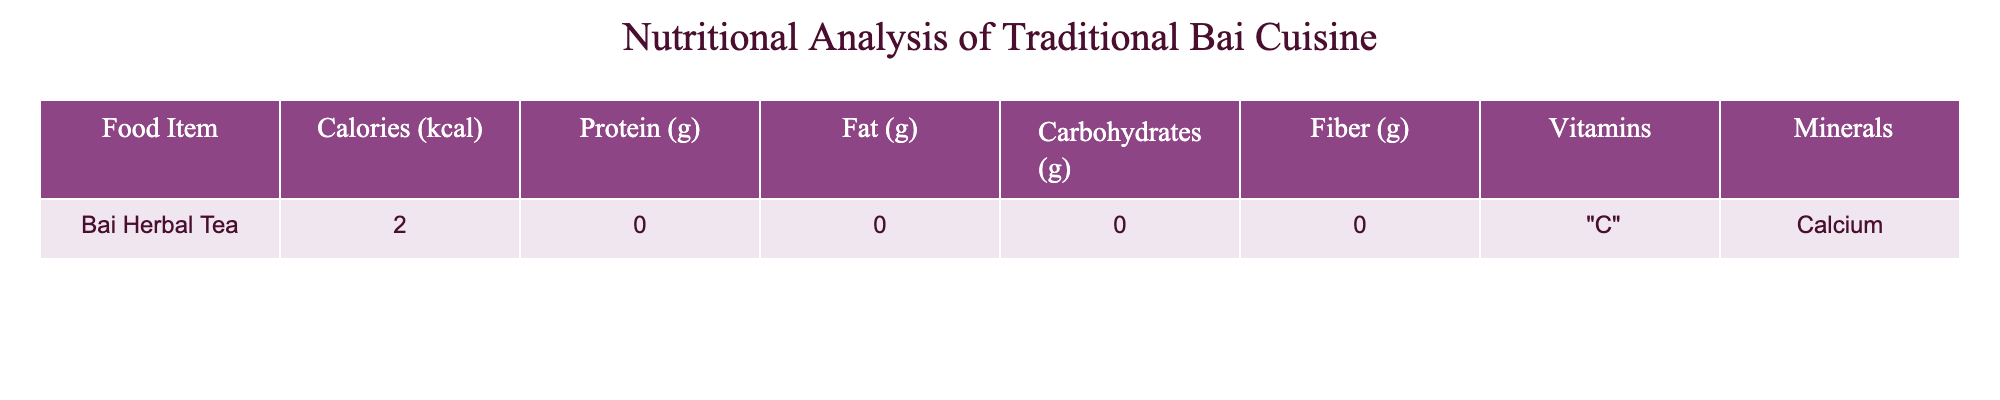What is the calorie content of Bai Herbal Tea? The calorie content of Bai Herbal Tea is listed directly in the table under the "Calories (kcal)" column.
Answer: 2 kcal Does Bai Herbal Tea contain any protein? The "Protein (g)" column indicates that Bai Herbal Tea has 0 grams of protein.
Answer: No What is the total fat content in Bai Herbal Tea? The table shows a total fat content of 0 grams for Bai Herbal Tea in the "Fat (g)" column.
Answer: 0 g Is Bai Herbal Tea a significant source of vitamins? The table indicates that Bai Herbal Tea contains Vitamin C, which is a significant vitamin, thus it qualifies as a source of vitamins.
Answer: Yes If you were to consume 3 servings of Bai Herbal Tea, how many calories would that amount to? Each serving has 2 kcal, and thus 3 servings would be 2 * 3 = 6 kcal.
Answer: 6 kcal What percentage of carbohydrates does Bai Herbal Tea represent? The "Carbohydrates (g)" column shows 0 grams, which means the percentage of carbohydrates in Bai Herbal Tea is 0/2 * 100 = 0%.
Answer: 0% Are the minerals mentioned in Bai Herbal Tea considered nutritious? The table states that Bai Herbal Tea contains calcium, which is known to be an essential mineral, thus it is considered nutritious.
Answer: Yes What is the fiber content of Bai Herbal Tea when comparing its nutritional profile against other traditional Bai dishes? Since the table indicates 0 grams of fiber, it suggests Bai Herbal Tea does not contribute fiber compared to other dishes, which typically have higher fiber content.
Answer: 0 g How many total nutrients (vitamins and minerals combined) are identified in Bai Herbal Tea? The table indicates that there is 1 vitamin (C) and 1 mineral (Calcium), giving a total of 2 nutrients.
Answer: 2 nutrients 